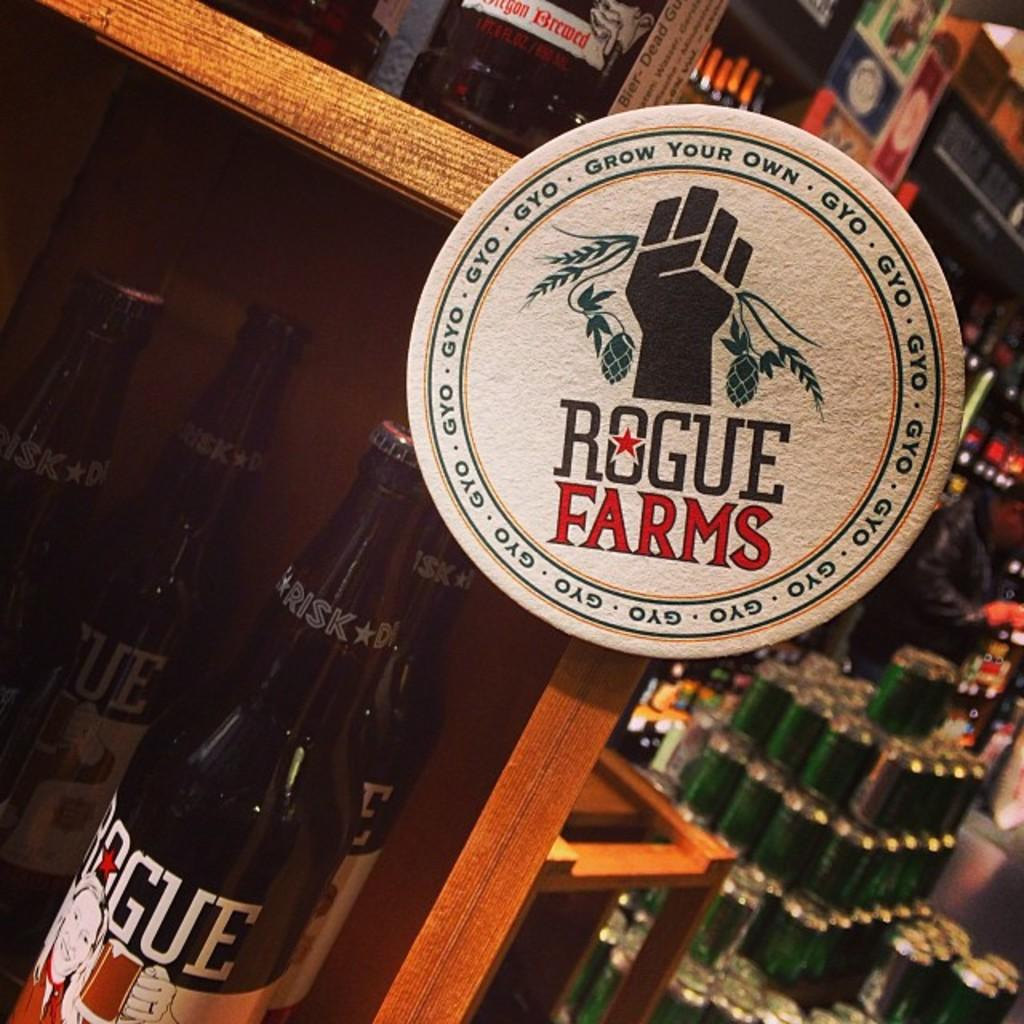<image>
Relay a brief, clear account of the picture shown. the words rogue farms are on the round item 